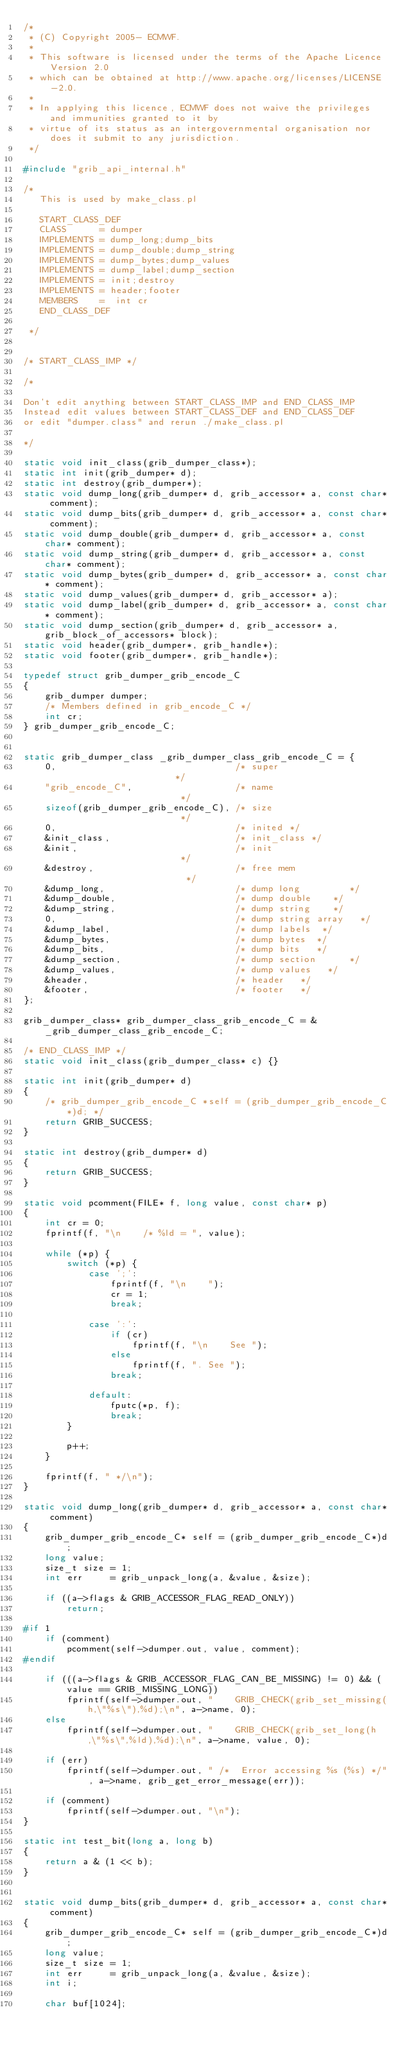Convert code to text. <code><loc_0><loc_0><loc_500><loc_500><_C_>/*
 * (C) Copyright 2005- ECMWF.
 *
 * This software is licensed under the terms of the Apache Licence Version 2.0
 * which can be obtained at http://www.apache.org/licenses/LICENSE-2.0.
 *
 * In applying this licence, ECMWF does not waive the privileges and immunities granted to it by
 * virtue of its status as an intergovernmental organisation nor does it submit to any jurisdiction.
 */

#include "grib_api_internal.h"

/*
   This is used by make_class.pl

   START_CLASS_DEF
   CLASS      = dumper
   IMPLEMENTS = dump_long;dump_bits
   IMPLEMENTS = dump_double;dump_string
   IMPLEMENTS = dump_bytes;dump_values
   IMPLEMENTS = dump_label;dump_section
   IMPLEMENTS = init;destroy
   IMPLEMENTS = header;footer
   MEMBERS    =  int cr
   END_CLASS_DEF

 */


/* START_CLASS_IMP */

/*

Don't edit anything between START_CLASS_IMP and END_CLASS_IMP
Instead edit values between START_CLASS_DEF and END_CLASS_DEF
or edit "dumper.class" and rerun ./make_class.pl

*/

static void init_class(grib_dumper_class*);
static int init(grib_dumper* d);
static int destroy(grib_dumper*);
static void dump_long(grib_dumper* d, grib_accessor* a, const char* comment);
static void dump_bits(grib_dumper* d, grib_accessor* a, const char* comment);
static void dump_double(grib_dumper* d, grib_accessor* a, const char* comment);
static void dump_string(grib_dumper* d, grib_accessor* a, const char* comment);
static void dump_bytes(grib_dumper* d, grib_accessor* a, const char* comment);
static void dump_values(grib_dumper* d, grib_accessor* a);
static void dump_label(grib_dumper* d, grib_accessor* a, const char* comment);
static void dump_section(grib_dumper* d, grib_accessor* a, grib_block_of_accessors* block);
static void header(grib_dumper*, grib_handle*);
static void footer(grib_dumper*, grib_handle*);

typedef struct grib_dumper_grib_encode_C
{
    grib_dumper dumper;
    /* Members defined in grib_encode_C */
    int cr;
} grib_dumper_grib_encode_C;


static grib_dumper_class _grib_dumper_class_grib_encode_C = {
    0,                                 /* super                     */
    "grib_encode_C",                   /* name                      */
    sizeof(grib_dumper_grib_encode_C), /* size                      */
    0,                                 /* inited */
    &init_class,                       /* init_class */
    &init,                             /* init                      */
    &destroy,                          /* free mem                       */
    &dump_long,                        /* dump long         */
    &dump_double,                      /* dump double    */
    &dump_string,                      /* dump string    */
    0,                                 /* dump string array   */
    &dump_label,                       /* dump labels  */
    &dump_bytes,                       /* dump bytes  */
    &dump_bits,                        /* dump bits   */
    &dump_section,                     /* dump section      */
    &dump_values,                      /* dump values   */
    &header,                           /* header   */
    &footer,                           /* footer   */
};

grib_dumper_class* grib_dumper_class_grib_encode_C = &_grib_dumper_class_grib_encode_C;

/* END_CLASS_IMP */
static void init_class(grib_dumper_class* c) {}

static int init(grib_dumper* d)
{
    /* grib_dumper_grib_encode_C *self = (grib_dumper_grib_encode_C*)d; */
    return GRIB_SUCCESS;
}

static int destroy(grib_dumper* d)
{
    return GRIB_SUCCESS;
}

static void pcomment(FILE* f, long value, const char* p)
{
    int cr = 0;
    fprintf(f, "\n    /* %ld = ", value);

    while (*p) {
        switch (*p) {
            case ';':
                fprintf(f, "\n    ");
                cr = 1;
                break;

            case ':':
                if (cr)
                    fprintf(f, "\n    See ");
                else
                    fprintf(f, ". See ");
                break;

            default:
                fputc(*p, f);
                break;
        }

        p++;
    }

    fprintf(f, " */\n");
}

static void dump_long(grib_dumper* d, grib_accessor* a, const char* comment)
{
    grib_dumper_grib_encode_C* self = (grib_dumper_grib_encode_C*)d;
    long value;
    size_t size = 1;
    int err     = grib_unpack_long(a, &value, &size);

    if ((a->flags & GRIB_ACCESSOR_FLAG_READ_ONLY))
        return;

#if 1
    if (comment)
        pcomment(self->dumper.out, value, comment);
#endif

    if (((a->flags & GRIB_ACCESSOR_FLAG_CAN_BE_MISSING) != 0) && (value == GRIB_MISSING_LONG))
        fprintf(self->dumper.out, "    GRIB_CHECK(grib_set_missing(h,\"%s\"),%d);\n", a->name, 0);
    else
        fprintf(self->dumper.out, "    GRIB_CHECK(grib_set_long(h,\"%s\",%ld),%d);\n", a->name, value, 0);

    if (err)
        fprintf(self->dumper.out, " /*  Error accessing %s (%s) */", a->name, grib_get_error_message(err));

    if (comment)
        fprintf(self->dumper.out, "\n");
}

static int test_bit(long a, long b)
{
    return a & (1 << b);
}


static void dump_bits(grib_dumper* d, grib_accessor* a, const char* comment)
{
    grib_dumper_grib_encode_C* self = (grib_dumper_grib_encode_C*)d;
    long value;
    size_t size = 1;
    int err     = grib_unpack_long(a, &value, &size);
    int i;

    char buf[1024];
</code> 